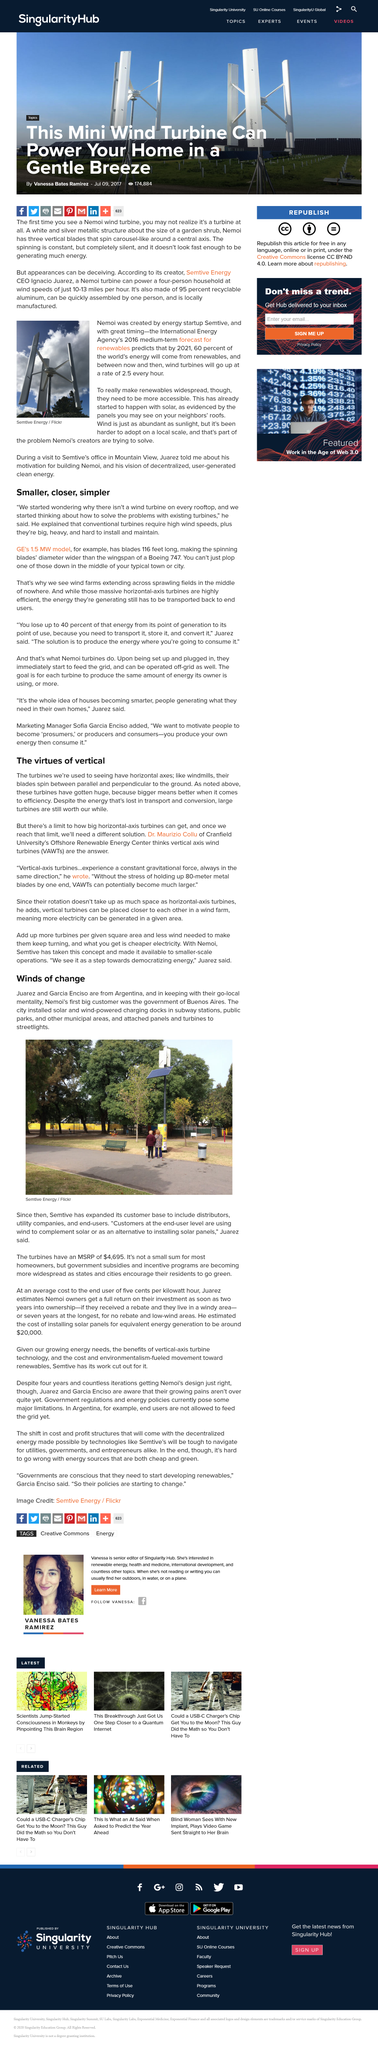Mention a couple of crucial points in this snapshot. The street light is attached to a solar panel, which generates electricity through the conversion of sunlight into energy. The International Energy Agency's medium-term forecast projects that by 2021, 60% of the world's energy will come from renewable sources, and wind turbines will be installed at an average rate of 2.5 per hour over the next few years. Nemoi, the decentralized, user-generated energy trading platform built on the Ethereum blockchain, was created by energy startup Semtive. This innovative company envisioned a future of decentralized, user-generated clean energy, and set out to make it a reality by building Nemoi. The platform's purpose is to help accelerate the adoption of wind energy by enabling users to trade energy directly with one another, regardless of their location or energy source. The article is based on Argentina. To prevent high energy loss from transport, it is necessary to produce the energy where it will be consumed. 